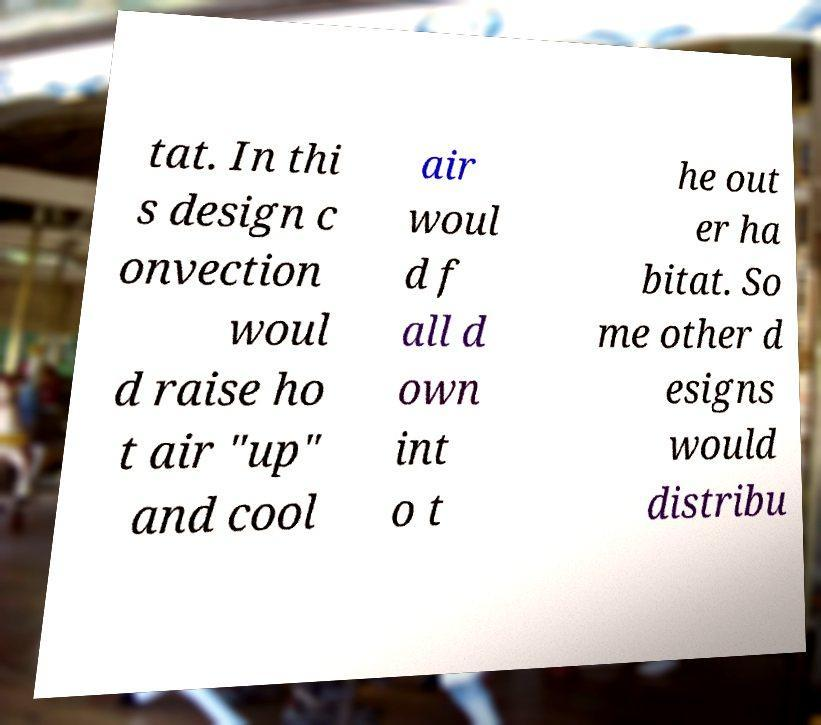Please identify and transcribe the text found in this image. tat. In thi s design c onvection woul d raise ho t air "up" and cool air woul d f all d own int o t he out er ha bitat. So me other d esigns would distribu 